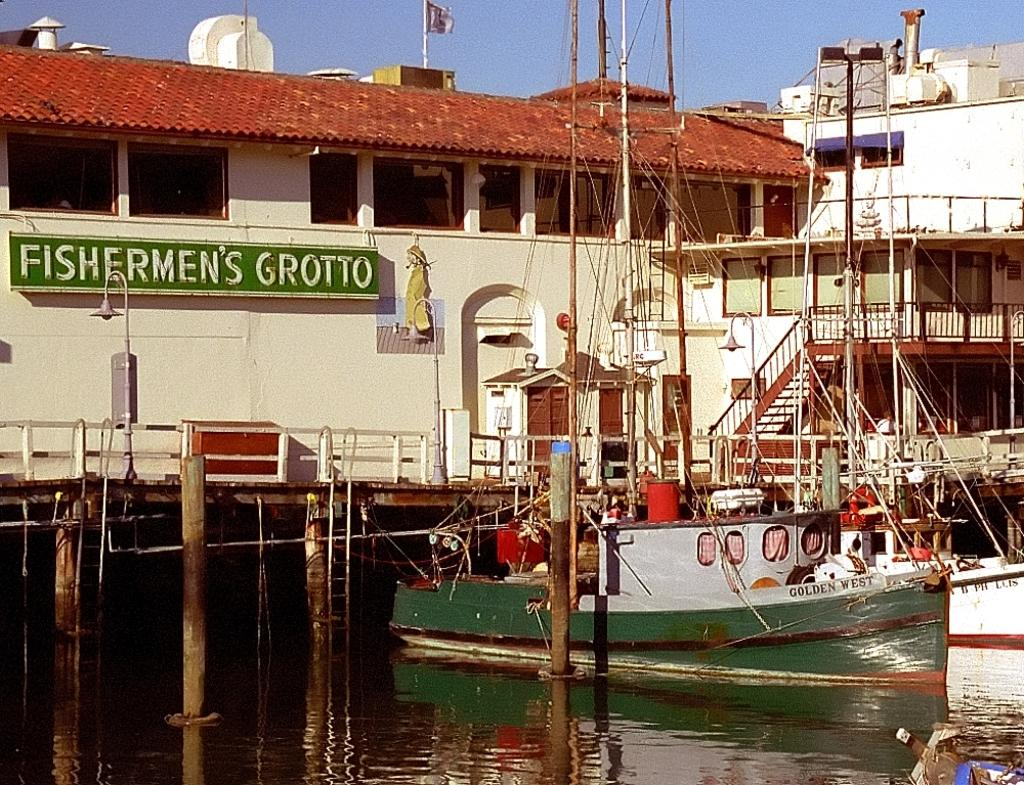<image>
Provide a brief description of the given image. A green fishing boat sits in the water next to the Fishermans Grotto. 